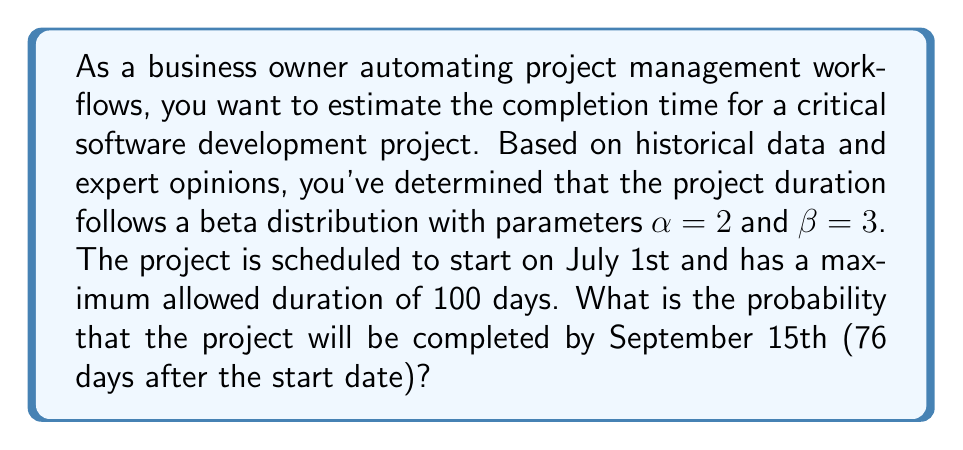What is the answer to this math problem? To solve this problem, we need to use the cumulative distribution function (CDF) of the beta distribution. The steps are as follows:

1) First, we need to normalize the given time frame to fit the beta distribution, which is defined on the interval [0, 1]. The maximum duration is 100 days, and we want to know the probability of completion by 76 days.

   Normalized time = $\frac{76}{100} = 0.76$

2) The CDF of the beta distribution is given by the regularized incomplete beta function:

   $$F(x; \alpha, \beta) = \frac{B(x; \alpha, \beta)}{B(\alpha, \beta)}$$

   Where $B(x; \alpha, \beta)$ is the incomplete beta function and $B(\alpha, \beta)$ is the beta function.

3) In this case, we need to calculate:

   $$F(0.76; 2, 3) = \frac{B(0.76; 2, 3)}{B(2, 3)}$$

4) The beta function $B(2, 3)$ can be calculated as:

   $$B(2, 3) = \frac{\Gamma(2)\Gamma(3)}{\Gamma(2+3)} = \frac{1 \cdot 2}{12} = \frac{1}{6}$$

5) The incomplete beta function $B(0.76; 2, 3)$ doesn't have a simple closed form and is typically calculated numerically. Using a statistical software or calculator, we can find:

   $$B(0.76; 2, 3) \approx 0.1466$$

6) Therefore, the probability is:

   $$F(0.76; 2, 3) = \frac{0.1466}{1/6} \approx 0.8796$$

This means there is approximately an 87.96% chance that the project will be completed by September 15th.
Answer: The probability that the project will be completed by September 15th is approximately 0.8796 or 87.96%. 